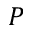<formula> <loc_0><loc_0><loc_500><loc_500>P</formula> 